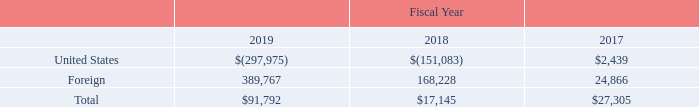12. INCOME TAXES
On December 22, 2017, the Tax Cuts and Jobs Act (“Tax Act”) was signed into law in the U.S. The Tax Act significantly revised the future ongoing U.S. corporate income tax by, among other things, lowering the U.S. corporate income tax rate to 21% from 35%, providing full expensing for investments in new and used qualified property made after September 27, 2017, and implementing a territorial tax system. In connection with the transition to the new territorial tax system, a one-time transition tax on certain unrepatriated earnings of foreign subsidiaries was imposed for fiscal 2018 (the “Transitional Repatriation Tax”), for which an election can be made to pay over eight years. In addition, the Tax Act included two new U.S. tax base erosion provisions, the Global Intangible Low-Taxed Income (“GILTI”) provisions and the Base- Erosion and Anti-Abuse Tax (“BEAT”) provisions, which became effective for the Company during fiscal 2019. The GILTI provisions generally result in inclusion of income earned by foreign subsidiaries in the U.S. taxable income.
In response to the Tax Act, the SEC issued Staff Accounting Bulletin No. 118 which allowed companies to recognize provisional estimates in the preparation of a Company’s financial statements and permitted up to a one year measurement period after the enactment date of the Tax Act to finalize the recording of the related tax impacts.
During fiscal 2018, the Company recorded a net provisional tax expense of $77.3 million for the estimated effects of the Tax Act. This was comprised of a provisional Transitional Repatriation Tax expense of $116.4 million, offset by a provisional deferred tax benefit of $39.1 million from the remeasurement of U.S. deferred tax assets and liabilities. The Company completed its analysis of the impact of the Tax Act during the third quarter of fiscal 2019, and during the first three quarters of fiscal 2019 recorded a net discrete income tax benefit adjustment of $17.0 million to the prior year provisional estimates, comprised of a $1.9 million reduction to the provisional Transitional Repatriation Tax and a $15.1 million increase in U.S. deferred tax assets.
The GILTI provisions became effective for the Company in fiscal 2019 and resulted in a net $30.4 million tax expense, consisting of a $70.8 million expense related to the inclusion of unremitted foreign earnings offset by a $40.4 million tax benefit from additional foreign tax credits. The Company has made an accounting policy decision under U.S. GAAP to treat taxes due on future GILTI inclusions in U.S. taxable income as a current-period expense (the “period cost method”).
Income (loss) before income taxes consists of the following components (in thousands):
What are the company's respective loss before income taxes from the United States in 2018 and 2019?
Answer scale should be: thousand. 151,083, 297,975. What are the company's respective foreign income before taxes in 2018 and 2019?
Answer scale should be: thousand. 168,228, 389,767. What are the company's respective total income before income taxes in 2018 and 2019?
Answer scale should be: thousand. 17,145, 91,792. What is the company's average loss before income taxes from the United States in 2018 and 2019?
Answer scale should be: thousand. (151,083 + 297,975)/2 
Answer: 224529. What is the company's average foreign income before taxes in 2018 and 2019?
Answer scale should be: thousand. (168,228 + 389,767)/2 
Answer: 278997.5. What is the company's average total income before income taxes in 2018 and 2019?
Answer scale should be: thousand. (17,145 + 91,792)/2 
Answer: 54468.5. 